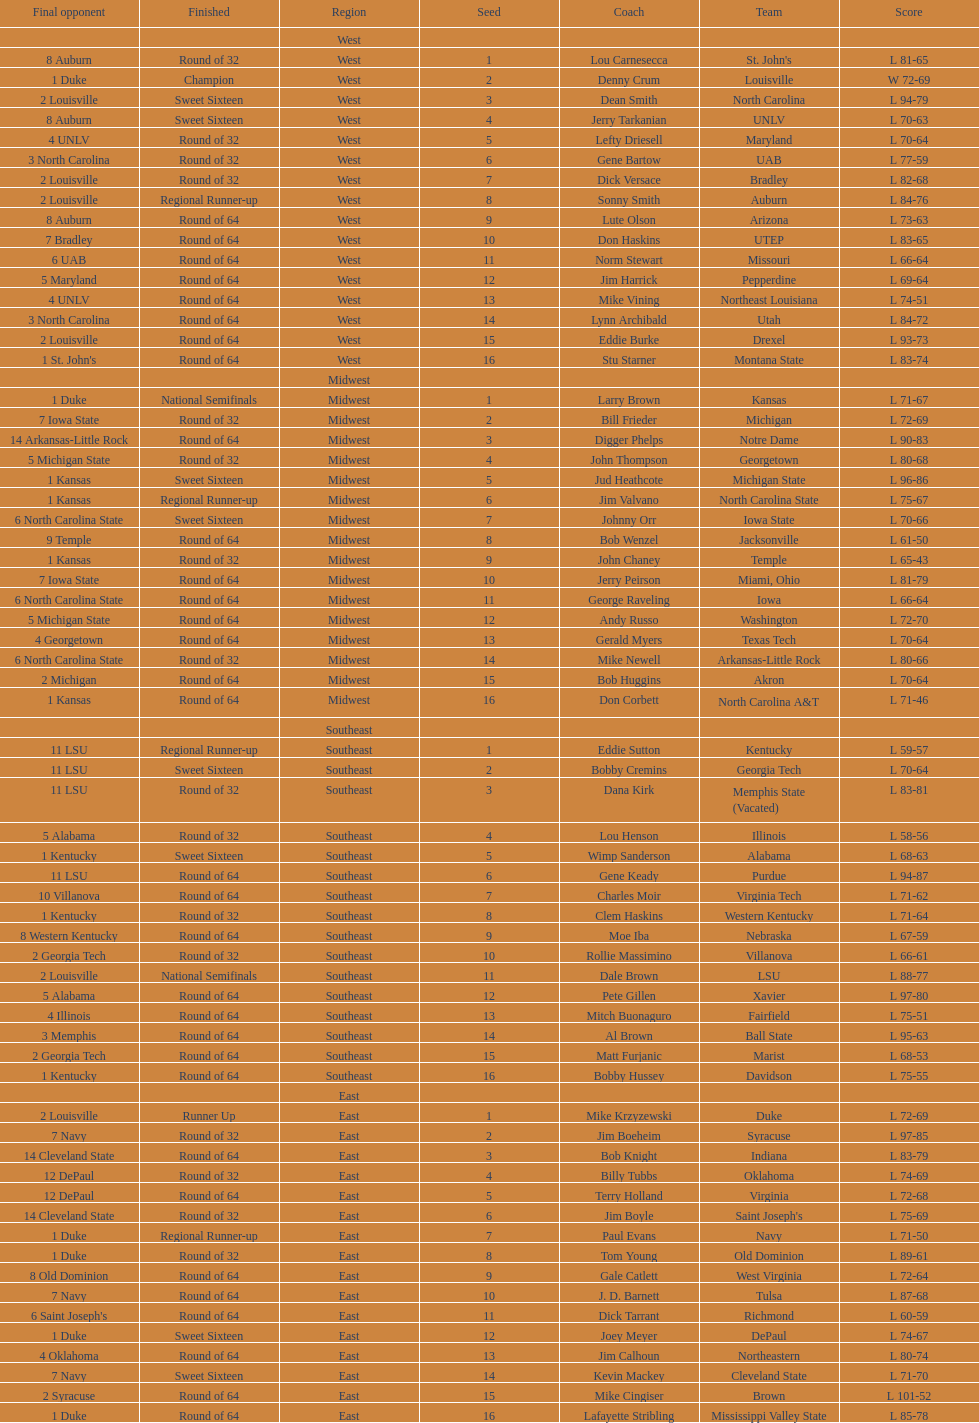What region is listed before the midwest? West. 